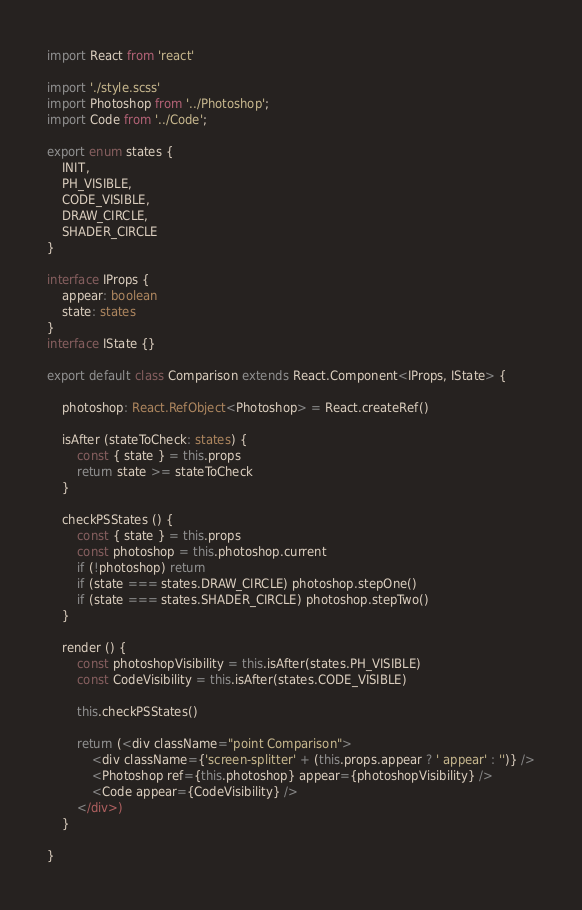<code> <loc_0><loc_0><loc_500><loc_500><_TypeScript_>import React from 'react'

import './style.scss'
import Photoshop from '../Photoshop';
import Code from '../Code';

export enum states {
    INIT,
    PH_VISIBLE,
    CODE_VISIBLE,
    DRAW_CIRCLE,
    SHADER_CIRCLE
}

interface IProps {
    appear: boolean
    state: states
}
interface IState {}

export default class Comparison extends React.Component<IProps, IState> {
    
    photoshop: React.RefObject<Photoshop> = React.createRef()

    isAfter (stateToCheck: states) {
        const { state } = this.props
        return state >= stateToCheck
    }

    checkPSStates () {
        const { state } = this.props
        const photoshop = this.photoshop.current
        if (!photoshop) return
        if (state === states.DRAW_CIRCLE) photoshop.stepOne()
        if (state === states.SHADER_CIRCLE) photoshop.stepTwo()
    }

    render () {
        const photoshopVisibility = this.isAfter(states.PH_VISIBLE)
        const CodeVisibility = this.isAfter(states.CODE_VISIBLE)

        this.checkPSStates()

        return (<div className="point Comparison">
            <div className={'screen-splitter' + (this.props.appear ? ' appear' : '')} />
            <Photoshop ref={this.photoshop} appear={photoshopVisibility} />
            <Code appear={CodeVisibility} />
        </div>)
    }

}</code> 